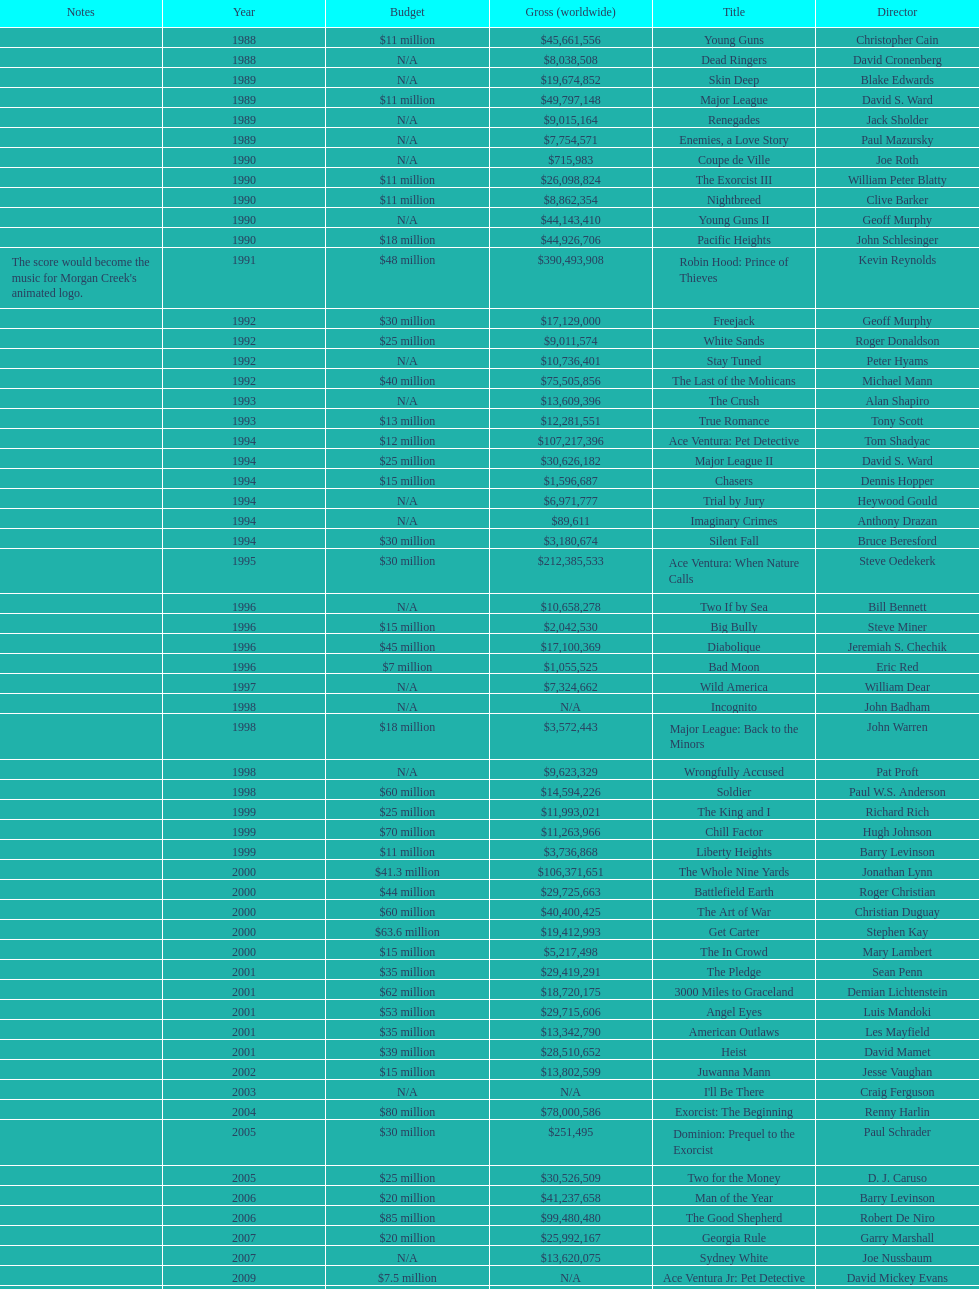Did true romance make more or less money than diabolique? Less. 